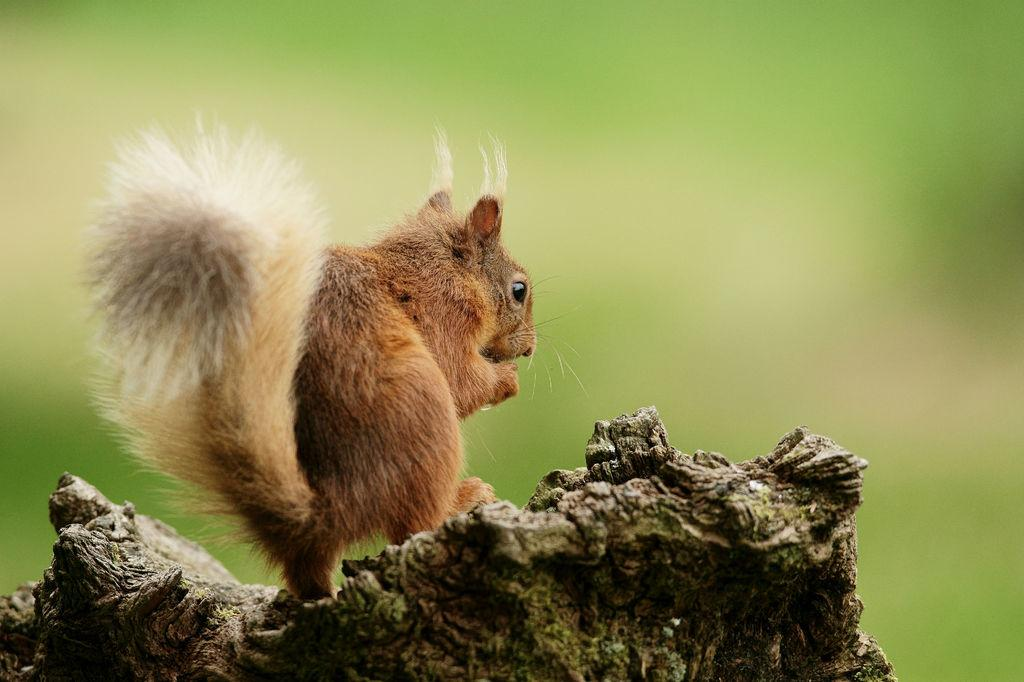What is the main object in the center of the image? There is a piece of wood in the center of the image. What is on top of the piece of wood? There is a squirrel on the wood. Can you describe the appearance of the squirrel? The squirrel is brown and white in color. What type of room can be seen in the background of the image? There is no room visible in the image; it only features a piece of wood with a squirrel on it. 